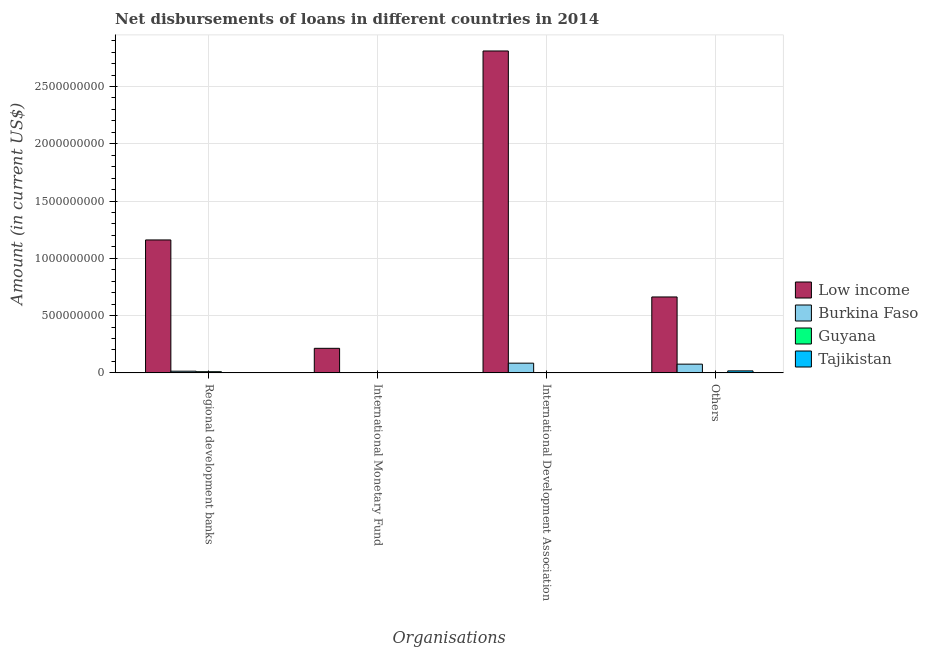Are the number of bars per tick equal to the number of legend labels?
Provide a succinct answer. No. How many bars are there on the 1st tick from the left?
Give a very brief answer. 3. How many bars are there on the 3rd tick from the right?
Ensure brevity in your answer.  1. What is the label of the 3rd group of bars from the left?
Ensure brevity in your answer.  International Development Association. What is the amount of loan disimbursed by other organisations in Tajikistan?
Make the answer very short. 1.73e+07. Across all countries, what is the maximum amount of loan disimbursed by international monetary fund?
Offer a terse response. 2.14e+08. In which country was the amount of loan disimbursed by other organisations maximum?
Provide a succinct answer. Low income. What is the total amount of loan disimbursed by other organisations in the graph?
Your response must be concise. 7.57e+08. What is the difference between the amount of loan disimbursed by other organisations in Burkina Faso and that in Guyana?
Ensure brevity in your answer.  7.48e+07. What is the difference between the amount of loan disimbursed by international monetary fund in Low income and the amount of loan disimbursed by other organisations in Guyana?
Your answer should be very brief. 2.13e+08. What is the average amount of loan disimbursed by international development association per country?
Offer a very short reply. 7.24e+08. What is the difference between the amount of loan disimbursed by international development association and amount of loan disimbursed by international monetary fund in Low income?
Your answer should be compact. 2.60e+09. What is the ratio of the amount of loan disimbursed by regional development banks in Low income to that in Guyana?
Offer a terse response. 115.73. What is the difference between the highest and the second highest amount of loan disimbursed by international development association?
Offer a terse response. 2.73e+09. What is the difference between the highest and the lowest amount of loan disimbursed by other organisations?
Provide a short and direct response. 6.61e+08. In how many countries, is the amount of loan disimbursed by regional development banks greater than the average amount of loan disimbursed by regional development banks taken over all countries?
Give a very brief answer. 1. Is it the case that in every country, the sum of the amount of loan disimbursed by regional development banks and amount of loan disimbursed by other organisations is greater than the sum of amount of loan disimbursed by international development association and amount of loan disimbursed by international monetary fund?
Provide a succinct answer. No. Are all the bars in the graph horizontal?
Your response must be concise. No. How many countries are there in the graph?
Make the answer very short. 4. What is the difference between two consecutive major ticks on the Y-axis?
Your answer should be very brief. 5.00e+08. How many legend labels are there?
Keep it short and to the point. 4. How are the legend labels stacked?
Your answer should be very brief. Vertical. What is the title of the graph?
Make the answer very short. Net disbursements of loans in different countries in 2014. What is the label or title of the X-axis?
Make the answer very short. Organisations. What is the label or title of the Y-axis?
Your answer should be compact. Amount (in current US$). What is the Amount (in current US$) in Low income in Regional development banks?
Offer a very short reply. 1.16e+09. What is the Amount (in current US$) in Burkina Faso in Regional development banks?
Provide a succinct answer. 1.46e+07. What is the Amount (in current US$) in Guyana in Regional development banks?
Provide a short and direct response. 1.00e+07. What is the Amount (in current US$) in Low income in International Monetary Fund?
Offer a very short reply. 2.14e+08. What is the Amount (in current US$) of Burkina Faso in International Monetary Fund?
Your answer should be very brief. 0. What is the Amount (in current US$) of Low income in International Development Association?
Offer a terse response. 2.81e+09. What is the Amount (in current US$) in Burkina Faso in International Development Association?
Offer a terse response. 8.47e+07. What is the Amount (in current US$) in Guyana in International Development Association?
Ensure brevity in your answer.  2.19e+06. What is the Amount (in current US$) of Tajikistan in International Development Association?
Your response must be concise. 0. What is the Amount (in current US$) of Low income in Others?
Give a very brief answer. 6.63e+08. What is the Amount (in current US$) in Burkina Faso in Others?
Keep it short and to the point. 7.61e+07. What is the Amount (in current US$) of Guyana in Others?
Make the answer very short. 1.31e+06. What is the Amount (in current US$) in Tajikistan in Others?
Give a very brief answer. 1.73e+07. Across all Organisations, what is the maximum Amount (in current US$) of Low income?
Give a very brief answer. 2.81e+09. Across all Organisations, what is the maximum Amount (in current US$) in Burkina Faso?
Offer a terse response. 8.47e+07. Across all Organisations, what is the maximum Amount (in current US$) in Guyana?
Give a very brief answer. 1.00e+07. Across all Organisations, what is the maximum Amount (in current US$) of Tajikistan?
Offer a terse response. 1.73e+07. Across all Organisations, what is the minimum Amount (in current US$) of Low income?
Ensure brevity in your answer.  2.14e+08. Across all Organisations, what is the minimum Amount (in current US$) in Burkina Faso?
Give a very brief answer. 0. What is the total Amount (in current US$) of Low income in the graph?
Your response must be concise. 4.85e+09. What is the total Amount (in current US$) in Burkina Faso in the graph?
Ensure brevity in your answer.  1.75e+08. What is the total Amount (in current US$) of Guyana in the graph?
Offer a very short reply. 1.35e+07. What is the total Amount (in current US$) of Tajikistan in the graph?
Offer a terse response. 1.73e+07. What is the difference between the Amount (in current US$) of Low income in Regional development banks and that in International Monetary Fund?
Your answer should be very brief. 9.46e+08. What is the difference between the Amount (in current US$) of Low income in Regional development banks and that in International Development Association?
Your answer should be compact. -1.65e+09. What is the difference between the Amount (in current US$) of Burkina Faso in Regional development banks and that in International Development Association?
Provide a succinct answer. -7.01e+07. What is the difference between the Amount (in current US$) in Guyana in Regional development banks and that in International Development Association?
Your answer should be compact. 7.84e+06. What is the difference between the Amount (in current US$) in Low income in Regional development banks and that in Others?
Your answer should be very brief. 4.98e+08. What is the difference between the Amount (in current US$) of Burkina Faso in Regional development banks and that in Others?
Offer a terse response. -6.14e+07. What is the difference between the Amount (in current US$) in Guyana in Regional development banks and that in Others?
Make the answer very short. 8.72e+06. What is the difference between the Amount (in current US$) of Low income in International Monetary Fund and that in International Development Association?
Give a very brief answer. -2.60e+09. What is the difference between the Amount (in current US$) in Low income in International Monetary Fund and that in Others?
Give a very brief answer. -4.48e+08. What is the difference between the Amount (in current US$) in Low income in International Development Association and that in Others?
Make the answer very short. 2.15e+09. What is the difference between the Amount (in current US$) in Burkina Faso in International Development Association and that in Others?
Your answer should be compact. 8.68e+06. What is the difference between the Amount (in current US$) in Guyana in International Development Association and that in Others?
Ensure brevity in your answer.  8.79e+05. What is the difference between the Amount (in current US$) of Low income in Regional development banks and the Amount (in current US$) of Burkina Faso in International Development Association?
Offer a very short reply. 1.08e+09. What is the difference between the Amount (in current US$) in Low income in Regional development banks and the Amount (in current US$) in Guyana in International Development Association?
Ensure brevity in your answer.  1.16e+09. What is the difference between the Amount (in current US$) in Burkina Faso in Regional development banks and the Amount (in current US$) in Guyana in International Development Association?
Your answer should be compact. 1.24e+07. What is the difference between the Amount (in current US$) of Low income in Regional development banks and the Amount (in current US$) of Burkina Faso in Others?
Make the answer very short. 1.08e+09. What is the difference between the Amount (in current US$) in Low income in Regional development banks and the Amount (in current US$) in Guyana in Others?
Provide a short and direct response. 1.16e+09. What is the difference between the Amount (in current US$) in Low income in Regional development banks and the Amount (in current US$) in Tajikistan in Others?
Ensure brevity in your answer.  1.14e+09. What is the difference between the Amount (in current US$) of Burkina Faso in Regional development banks and the Amount (in current US$) of Guyana in Others?
Give a very brief answer. 1.33e+07. What is the difference between the Amount (in current US$) of Burkina Faso in Regional development banks and the Amount (in current US$) of Tajikistan in Others?
Keep it short and to the point. -2.64e+06. What is the difference between the Amount (in current US$) in Guyana in Regional development banks and the Amount (in current US$) in Tajikistan in Others?
Keep it short and to the point. -7.23e+06. What is the difference between the Amount (in current US$) of Low income in International Monetary Fund and the Amount (in current US$) of Burkina Faso in International Development Association?
Make the answer very short. 1.30e+08. What is the difference between the Amount (in current US$) of Low income in International Monetary Fund and the Amount (in current US$) of Guyana in International Development Association?
Your answer should be compact. 2.12e+08. What is the difference between the Amount (in current US$) in Low income in International Monetary Fund and the Amount (in current US$) in Burkina Faso in Others?
Your answer should be compact. 1.38e+08. What is the difference between the Amount (in current US$) in Low income in International Monetary Fund and the Amount (in current US$) in Guyana in Others?
Provide a short and direct response. 2.13e+08. What is the difference between the Amount (in current US$) of Low income in International Monetary Fund and the Amount (in current US$) of Tajikistan in Others?
Keep it short and to the point. 1.97e+08. What is the difference between the Amount (in current US$) of Low income in International Development Association and the Amount (in current US$) of Burkina Faso in Others?
Offer a very short reply. 2.73e+09. What is the difference between the Amount (in current US$) in Low income in International Development Association and the Amount (in current US$) in Guyana in Others?
Ensure brevity in your answer.  2.81e+09. What is the difference between the Amount (in current US$) of Low income in International Development Association and the Amount (in current US$) of Tajikistan in Others?
Offer a very short reply. 2.79e+09. What is the difference between the Amount (in current US$) of Burkina Faso in International Development Association and the Amount (in current US$) of Guyana in Others?
Your answer should be very brief. 8.34e+07. What is the difference between the Amount (in current US$) of Burkina Faso in International Development Association and the Amount (in current US$) of Tajikistan in Others?
Ensure brevity in your answer.  6.75e+07. What is the difference between the Amount (in current US$) of Guyana in International Development Association and the Amount (in current US$) of Tajikistan in Others?
Your answer should be compact. -1.51e+07. What is the average Amount (in current US$) of Low income per Organisations?
Your response must be concise. 1.21e+09. What is the average Amount (in current US$) in Burkina Faso per Organisations?
Offer a terse response. 4.39e+07. What is the average Amount (in current US$) of Guyana per Organisations?
Your answer should be compact. 3.38e+06. What is the average Amount (in current US$) in Tajikistan per Organisations?
Your answer should be very brief. 4.31e+06. What is the difference between the Amount (in current US$) in Low income and Amount (in current US$) in Burkina Faso in Regional development banks?
Your answer should be compact. 1.15e+09. What is the difference between the Amount (in current US$) in Low income and Amount (in current US$) in Guyana in Regional development banks?
Ensure brevity in your answer.  1.15e+09. What is the difference between the Amount (in current US$) of Burkina Faso and Amount (in current US$) of Guyana in Regional development banks?
Make the answer very short. 4.59e+06. What is the difference between the Amount (in current US$) of Low income and Amount (in current US$) of Burkina Faso in International Development Association?
Keep it short and to the point. 2.73e+09. What is the difference between the Amount (in current US$) in Low income and Amount (in current US$) in Guyana in International Development Association?
Your response must be concise. 2.81e+09. What is the difference between the Amount (in current US$) of Burkina Faso and Amount (in current US$) of Guyana in International Development Association?
Your response must be concise. 8.26e+07. What is the difference between the Amount (in current US$) in Low income and Amount (in current US$) in Burkina Faso in Others?
Give a very brief answer. 5.87e+08. What is the difference between the Amount (in current US$) of Low income and Amount (in current US$) of Guyana in Others?
Provide a short and direct response. 6.61e+08. What is the difference between the Amount (in current US$) in Low income and Amount (in current US$) in Tajikistan in Others?
Make the answer very short. 6.45e+08. What is the difference between the Amount (in current US$) of Burkina Faso and Amount (in current US$) of Guyana in Others?
Keep it short and to the point. 7.48e+07. What is the difference between the Amount (in current US$) of Burkina Faso and Amount (in current US$) of Tajikistan in Others?
Provide a succinct answer. 5.88e+07. What is the difference between the Amount (in current US$) of Guyana and Amount (in current US$) of Tajikistan in Others?
Provide a short and direct response. -1.59e+07. What is the ratio of the Amount (in current US$) in Low income in Regional development banks to that in International Monetary Fund?
Offer a very short reply. 5.42. What is the ratio of the Amount (in current US$) of Low income in Regional development banks to that in International Development Association?
Ensure brevity in your answer.  0.41. What is the ratio of the Amount (in current US$) of Burkina Faso in Regional development banks to that in International Development Association?
Make the answer very short. 0.17. What is the ratio of the Amount (in current US$) of Guyana in Regional development banks to that in International Development Association?
Ensure brevity in your answer.  4.58. What is the ratio of the Amount (in current US$) of Low income in Regional development banks to that in Others?
Give a very brief answer. 1.75. What is the ratio of the Amount (in current US$) in Burkina Faso in Regional development banks to that in Others?
Offer a very short reply. 0.19. What is the ratio of the Amount (in current US$) of Guyana in Regional development banks to that in Others?
Offer a terse response. 7.66. What is the ratio of the Amount (in current US$) of Low income in International Monetary Fund to that in International Development Association?
Offer a terse response. 0.08. What is the ratio of the Amount (in current US$) of Low income in International Monetary Fund to that in Others?
Keep it short and to the point. 0.32. What is the ratio of the Amount (in current US$) of Low income in International Development Association to that in Others?
Offer a very short reply. 4.24. What is the ratio of the Amount (in current US$) in Burkina Faso in International Development Association to that in Others?
Your answer should be compact. 1.11. What is the ratio of the Amount (in current US$) of Guyana in International Development Association to that in Others?
Provide a short and direct response. 1.67. What is the difference between the highest and the second highest Amount (in current US$) of Low income?
Offer a terse response. 1.65e+09. What is the difference between the highest and the second highest Amount (in current US$) in Burkina Faso?
Provide a short and direct response. 8.68e+06. What is the difference between the highest and the second highest Amount (in current US$) of Guyana?
Ensure brevity in your answer.  7.84e+06. What is the difference between the highest and the lowest Amount (in current US$) of Low income?
Your response must be concise. 2.60e+09. What is the difference between the highest and the lowest Amount (in current US$) of Burkina Faso?
Give a very brief answer. 8.47e+07. What is the difference between the highest and the lowest Amount (in current US$) of Guyana?
Ensure brevity in your answer.  1.00e+07. What is the difference between the highest and the lowest Amount (in current US$) of Tajikistan?
Offer a very short reply. 1.73e+07. 